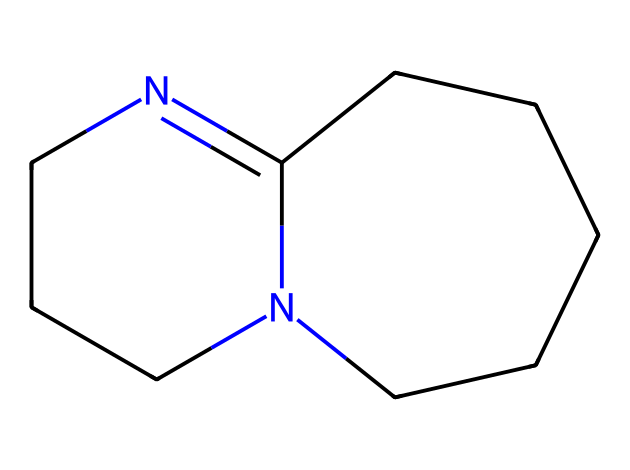What is the total number of carbon atoms in this structure? In the SMILES representation, each 'C' indicates a carbon atom. Counting the number of 'C' gives us a total of 8 carbon atoms in the structure.
Answer: 8 How many nitrogen atoms are present in 1,8-diazabicyclo[5.4.0]undec-7-ene? The SMILES representation includes two 'N' symbols, which each represent a nitrogen atom. Therefore, there are 2 nitrogen atoms in the structure.
Answer: 2 What type of molecular framework does DBU have? The structure contains a bicyclic framework indicated by the prefix "bicyclo" and the presence of multiple connected rings in the SMILES. This indicates a bicyclic structure.
Answer: bicyclic What functional group characterizes the DBU structure? DBU is classified as a superbase due to the presence of nitrogen atoms, particularly in a heterocyclic structure, making it a strong base. The nitrogen functionality is key here.
Answer: superbase What is the molecular formula of 1,8-diazabicyclo[5.4.0]undec-7-ene? To derive the molecular formula, we count the atoms in the structure: C=8, H=14 (inferred from the bonding), and N=2, leading to the formula C8H14N2.
Answer: C8H14N2 What role does the bicyclic nature play in the properties of DBU? The bicyclic structure increases the stability and basicity of the compound by creating a rigid framework that maintains the availability of lone pair electrons on nitrogen, facilitating its ability to act as a superbase in reactions.
Answer: stability and basicity 